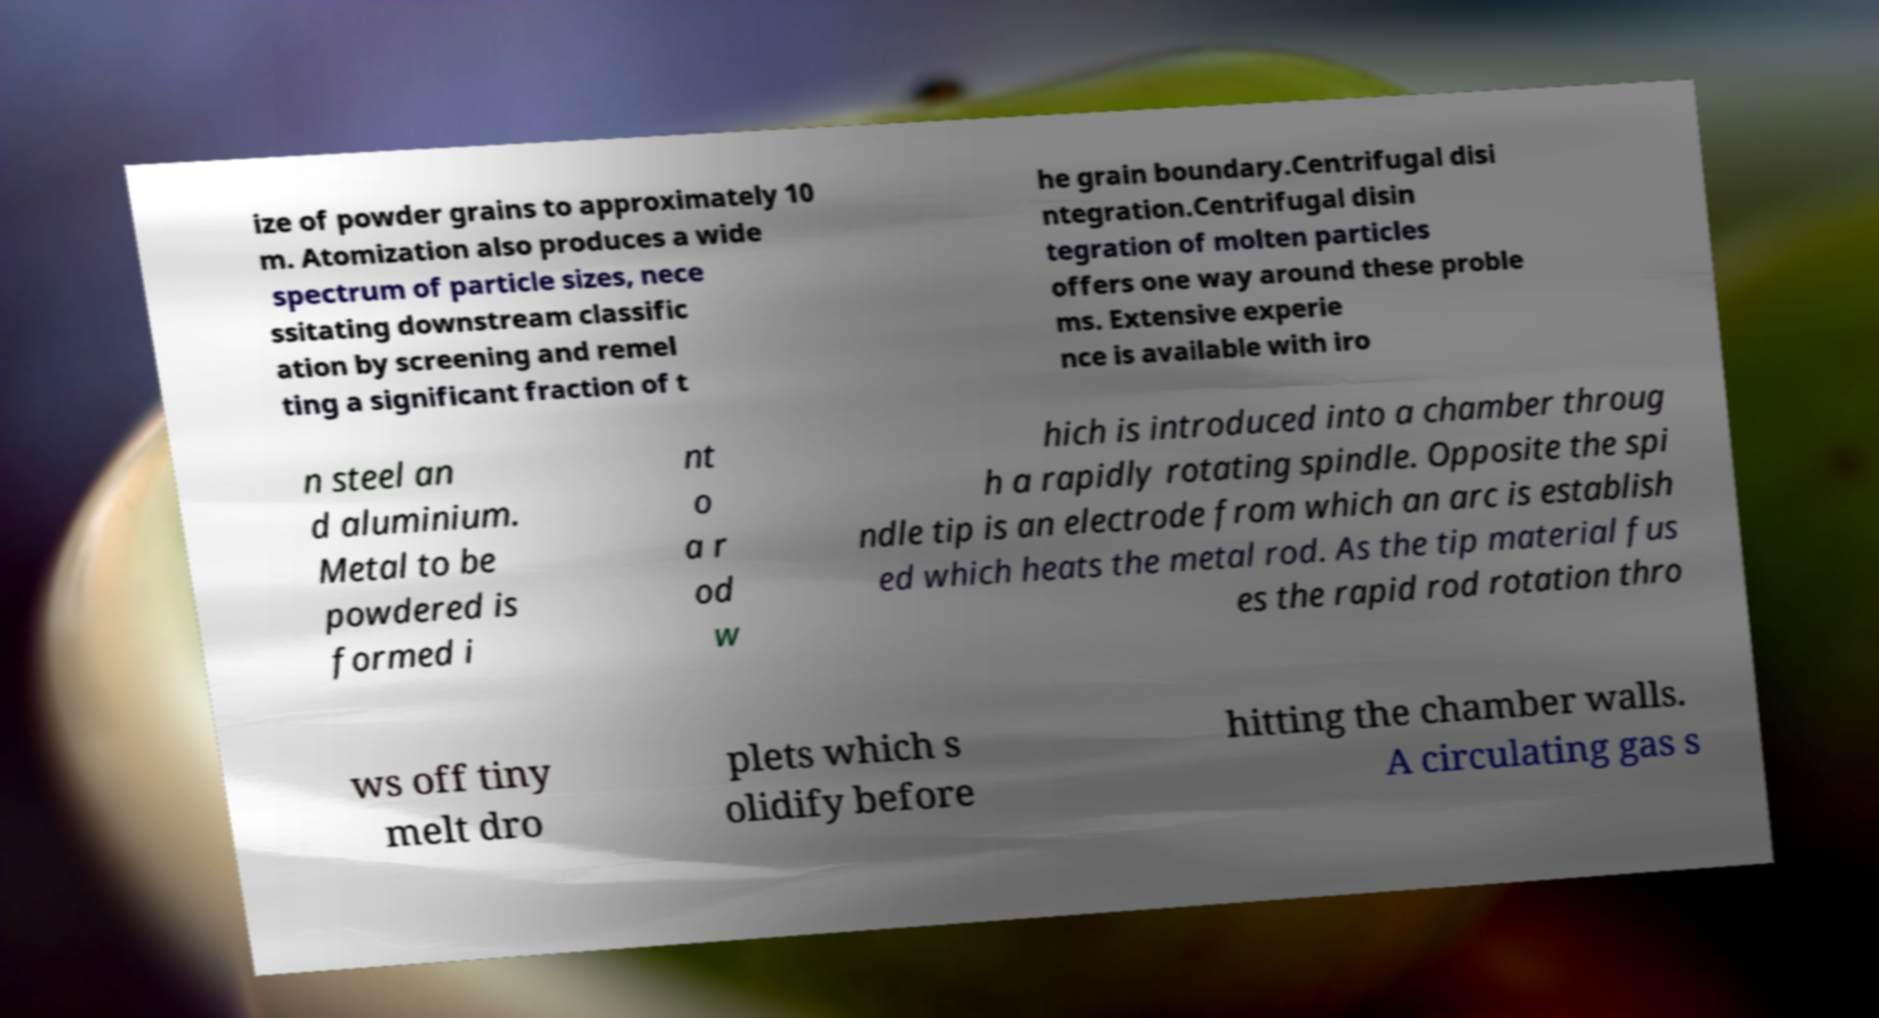Can you read and provide the text displayed in the image?This photo seems to have some interesting text. Can you extract and type it out for me? ize of powder grains to approximately 10 m. Atomization also produces a wide spectrum of particle sizes, nece ssitating downstream classific ation by screening and remel ting a significant fraction of t he grain boundary.Centrifugal disi ntegration.Centrifugal disin tegration of molten particles offers one way around these proble ms. Extensive experie nce is available with iro n steel an d aluminium. Metal to be powdered is formed i nt o a r od w hich is introduced into a chamber throug h a rapidly rotating spindle. Opposite the spi ndle tip is an electrode from which an arc is establish ed which heats the metal rod. As the tip material fus es the rapid rod rotation thro ws off tiny melt dro plets which s olidify before hitting the chamber walls. A circulating gas s 